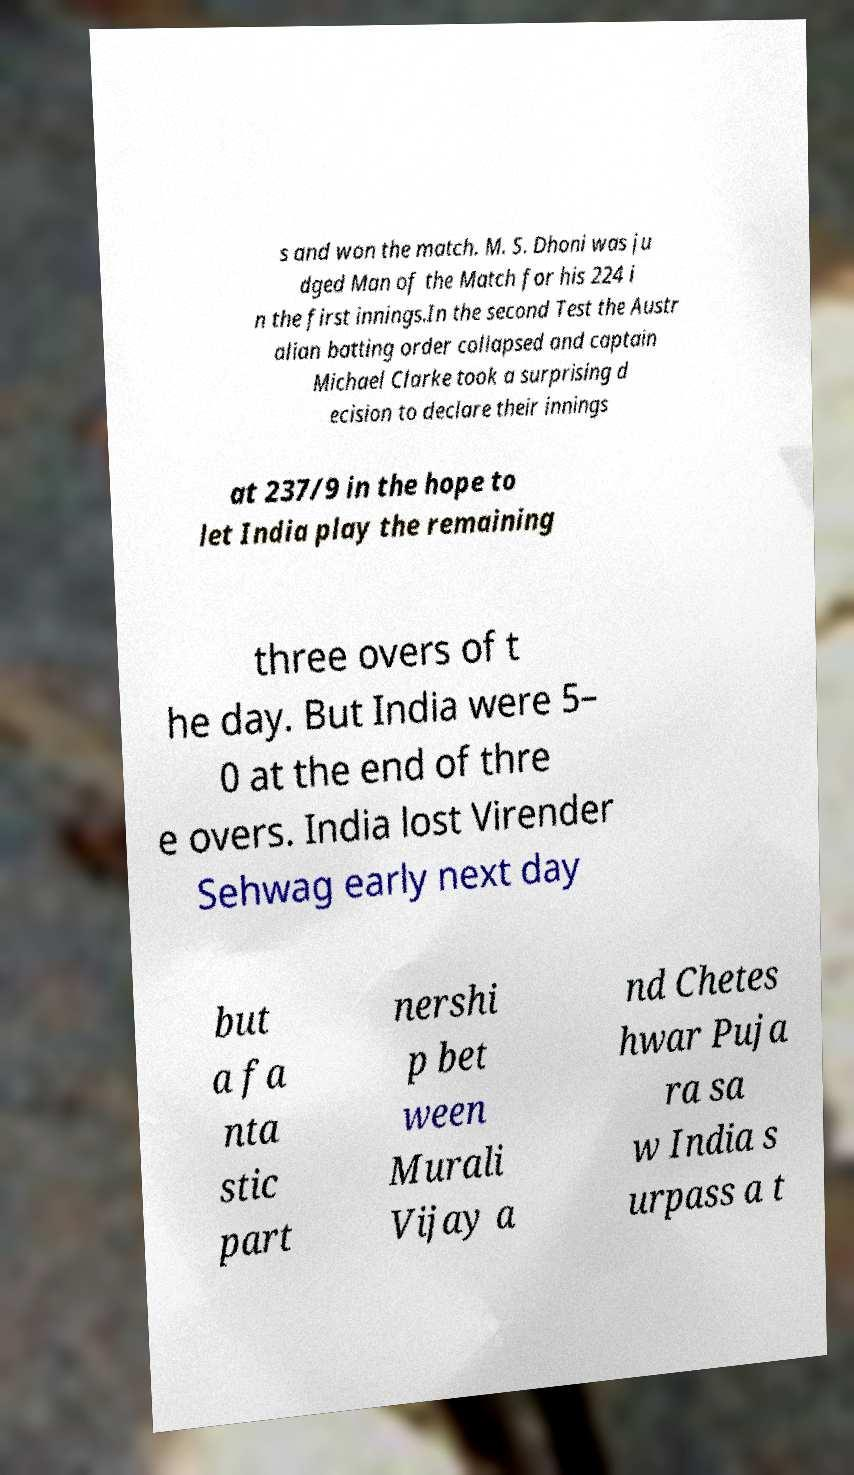What messages or text are displayed in this image? I need them in a readable, typed format. s and won the match. M. S. Dhoni was ju dged Man of the Match for his 224 i n the first innings.In the second Test the Austr alian batting order collapsed and captain Michael Clarke took a surprising d ecision to declare their innings at 237/9 in the hope to let India play the remaining three overs of t he day. But India were 5– 0 at the end of thre e overs. India lost Virender Sehwag early next day but a fa nta stic part nershi p bet ween Murali Vijay a nd Chetes hwar Puja ra sa w India s urpass a t 